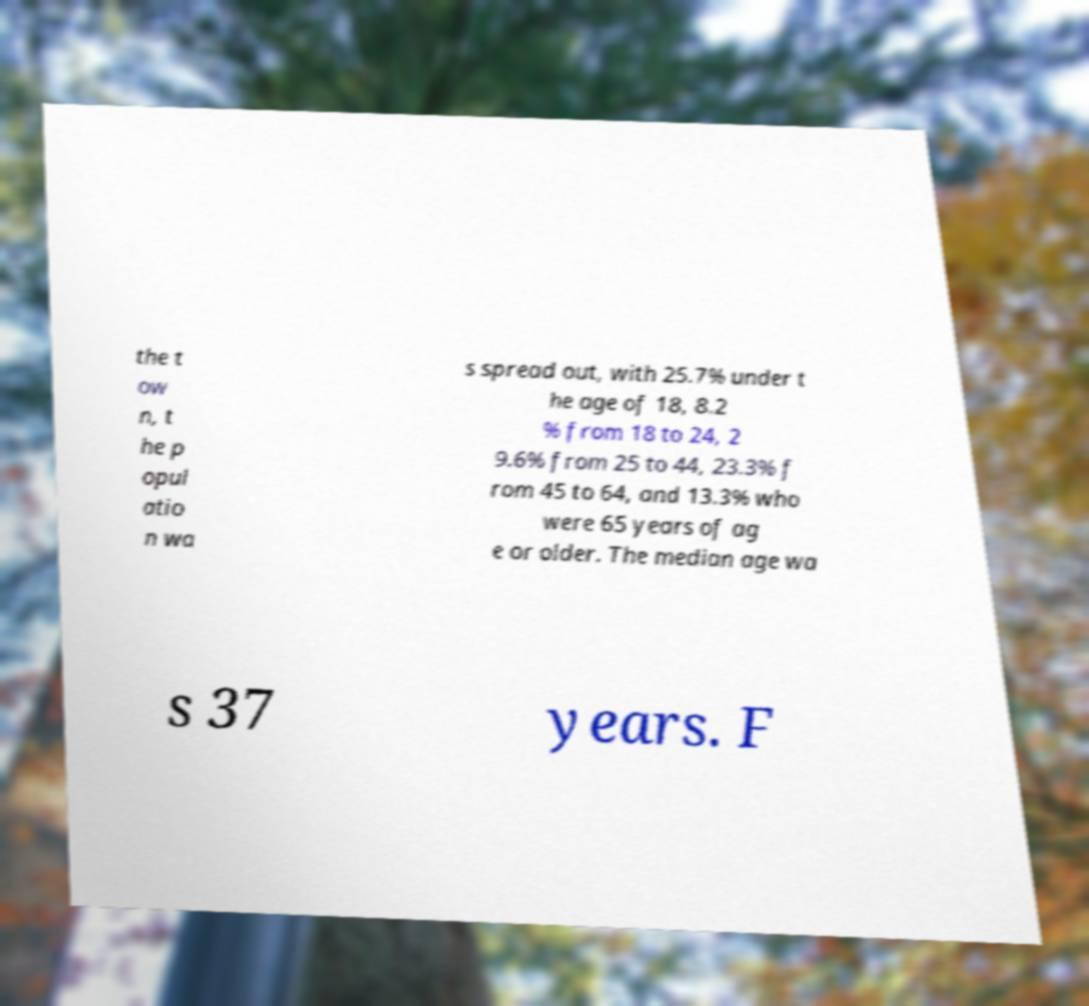Please identify and transcribe the text found in this image. the t ow n, t he p opul atio n wa s spread out, with 25.7% under t he age of 18, 8.2 % from 18 to 24, 2 9.6% from 25 to 44, 23.3% f rom 45 to 64, and 13.3% who were 65 years of ag e or older. The median age wa s 37 years. F 